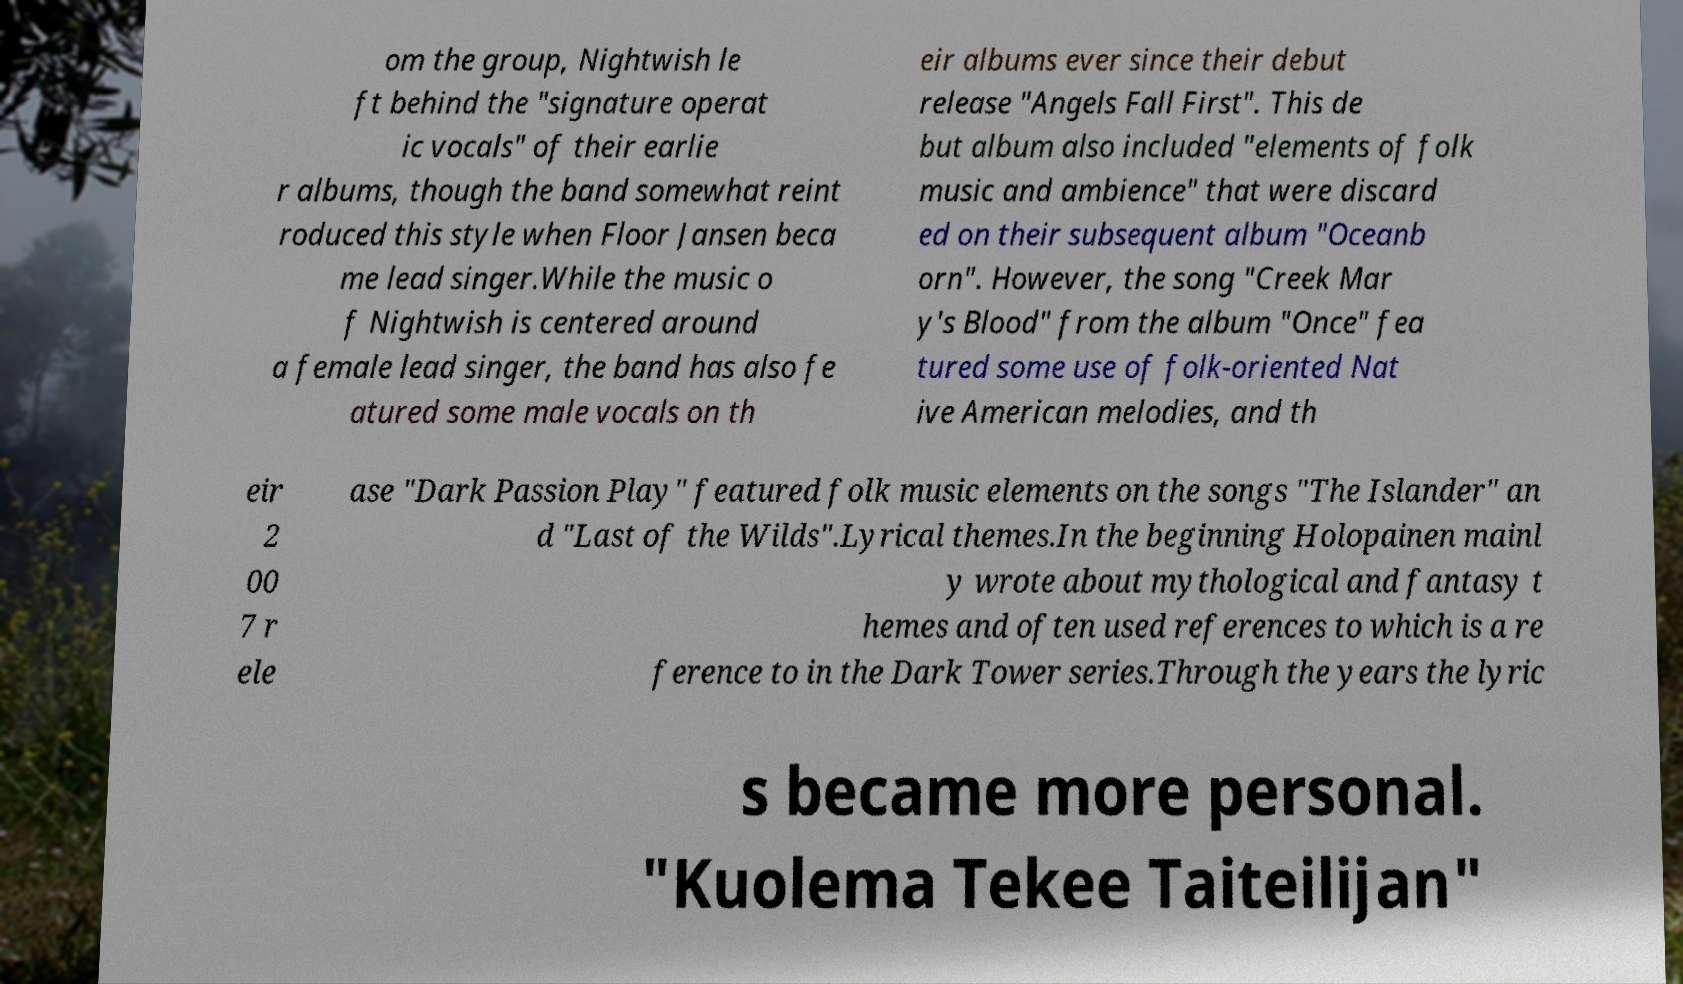What messages or text are displayed in this image? I need them in a readable, typed format. om the group, Nightwish le ft behind the "signature operat ic vocals" of their earlie r albums, though the band somewhat reint roduced this style when Floor Jansen beca me lead singer.While the music o f Nightwish is centered around a female lead singer, the band has also fe atured some male vocals on th eir albums ever since their debut release "Angels Fall First". This de but album also included "elements of folk music and ambience" that were discard ed on their subsequent album "Oceanb orn". However, the song "Creek Mar y's Blood" from the album "Once" fea tured some use of folk-oriented Nat ive American melodies, and th eir 2 00 7 r ele ase "Dark Passion Play" featured folk music elements on the songs "The Islander" an d "Last of the Wilds".Lyrical themes.In the beginning Holopainen mainl y wrote about mythological and fantasy t hemes and often used references to which is a re ference to in the Dark Tower series.Through the years the lyric s became more personal. "Kuolema Tekee Taiteilijan" 